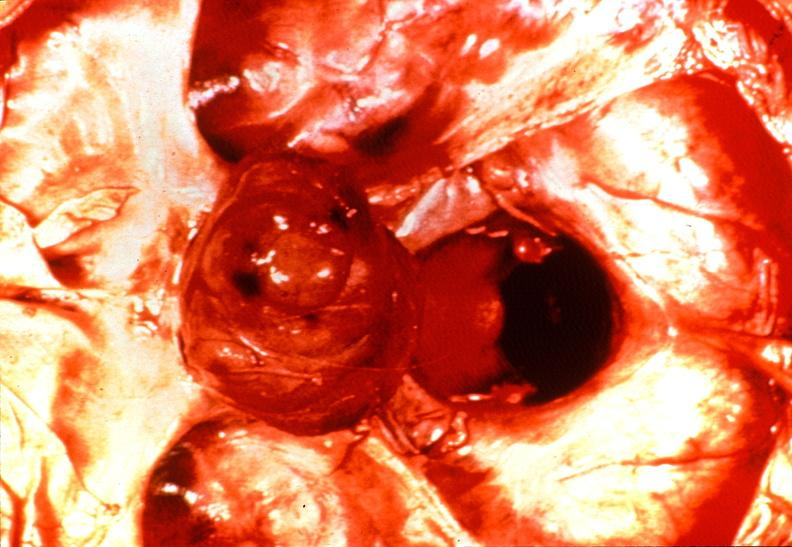does omentum show pituitary, chromaphobe adenoma?
Answer the question using a single word or phrase. No 